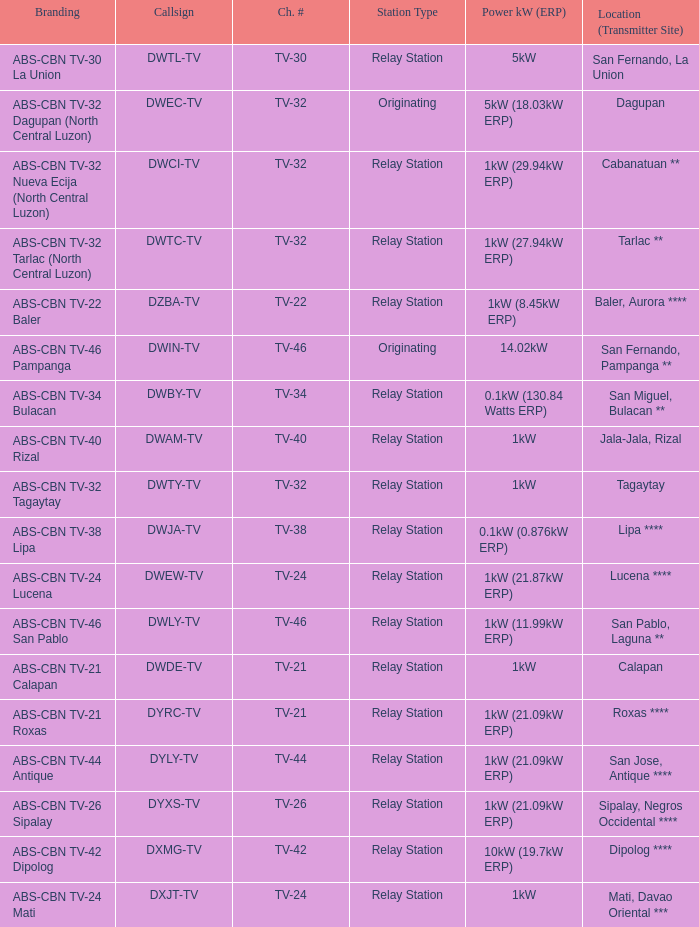What is the power output in kw (erp) at the san fernando, pampanga transmitter site? 14.02kW. 